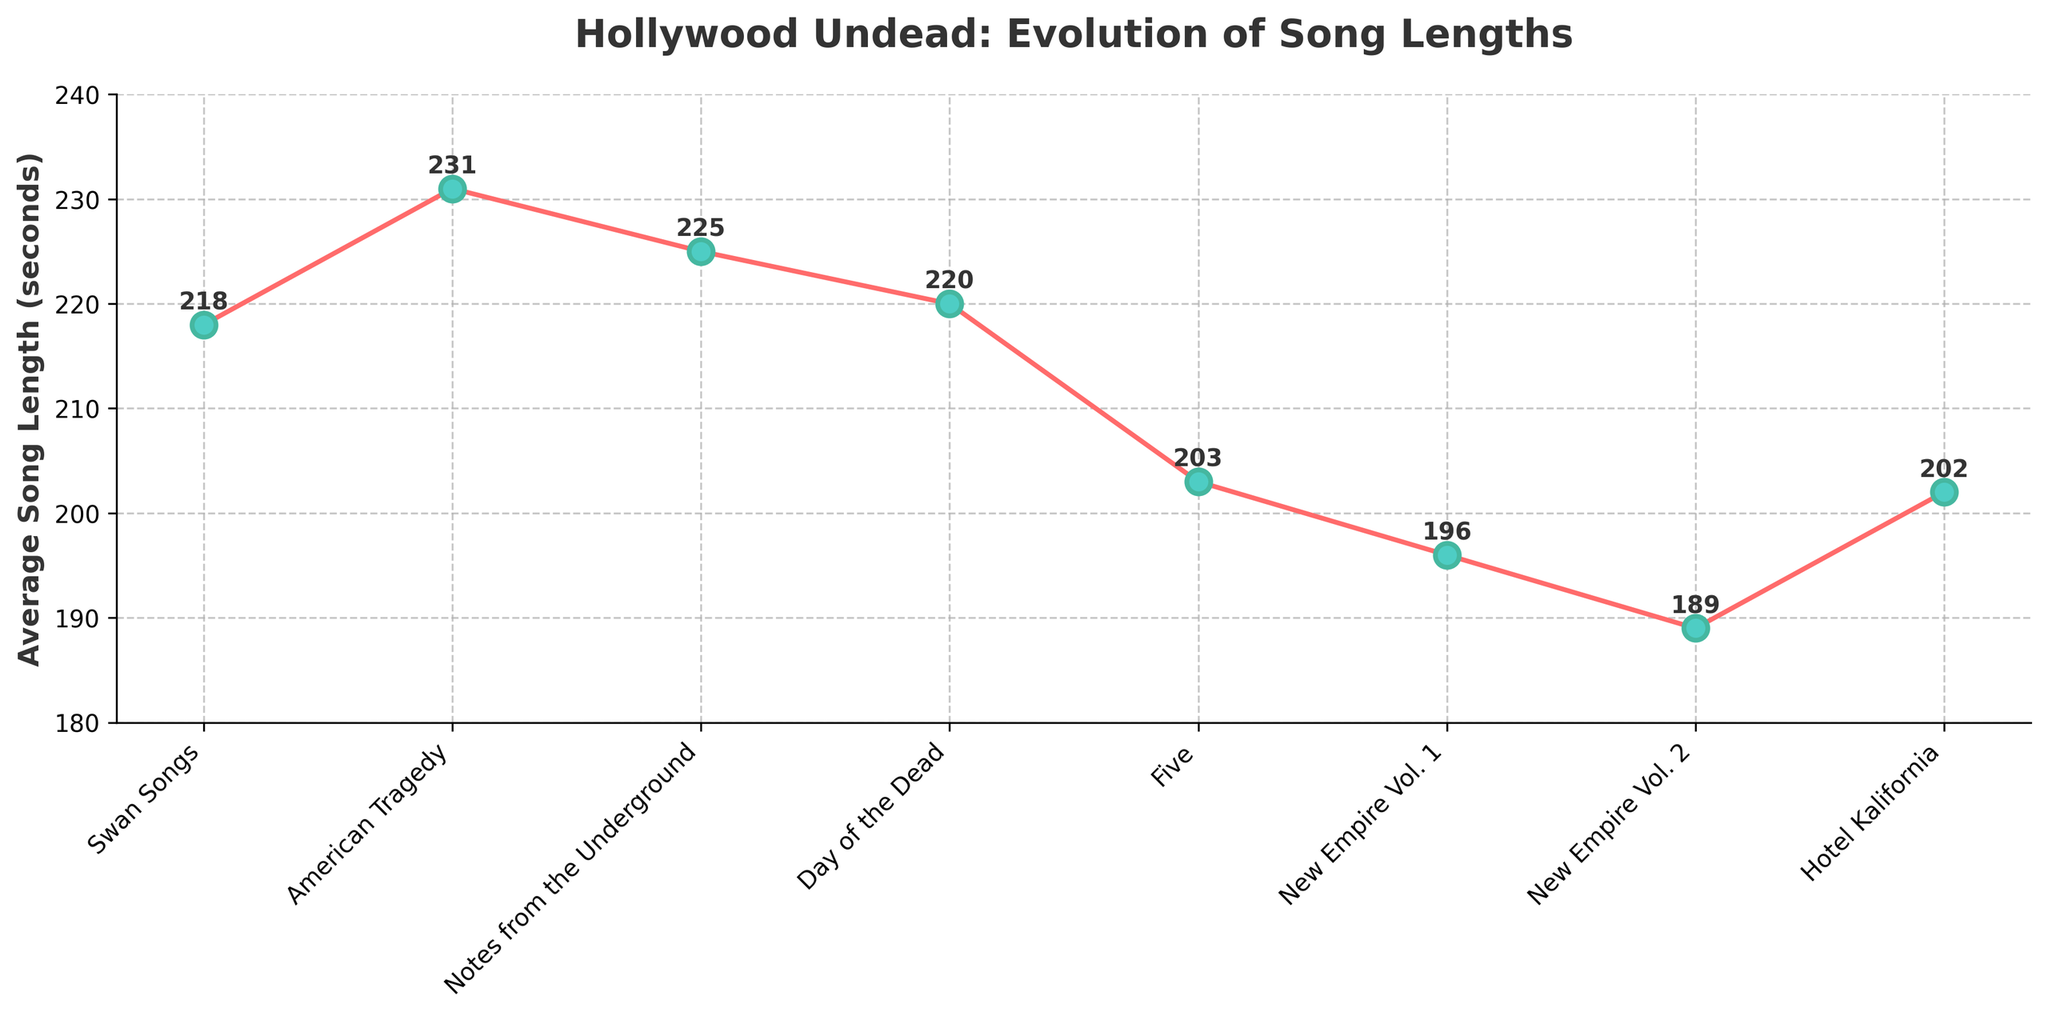How many albums have an average song length greater than 210 seconds? Look at each album's average song length and count how many are above 210 seconds. "Swan Songs" (218), "American Tragedy" (231), "Notes from the Underground" (225), and "Day of the Dead" (220) all have average song lengths greater than 210 seconds.
Answer: 4 Which album has the shortest average song length? Compare the average song length for all the albums. "New Empire Vol. 2" has the shortest average song length at 189 seconds.
Answer: New Empire Vol. 2 Are there any albums with the same average song length? Check the values of average song lengths and see if any values are repeated. There are no repeated values in this dataset.
Answer: No What is the difference in average song length between "American Tragedy" and "New Empire Vol. 1"? Subtract the average song length of "New Empire Vol. 1" from that of "American Tragedy": 231 - 196 = 35 seconds.
Answer: 35 seconds What is the overall trend in average song lengths over time? Observe the plot line or the sequence of average song lengths from "Swan Songs" to "Hotel Kalifornia". The trend shows a general decrease in average song lengths over time.
Answer: Decreasing Which album shows the largest change in average song length compared to its previous album? Calculate the absolute differences between consecutive albums: "Swan Songs" to "American Tragedy" (13), "American Tragedy" to "Notes from the Underground" (6), and so on. "American Tragedy" to "Five" shows the largest drop: 231 - 203 = 28 seconds.
Answer: American Tragedy to Five If you average the song lengths of "Day of the Dead" and "Hotel Kalifornia," what value do you get? Add the average song lengths of "Day of the Dead" and "Hotel Kalifornia" and divide by 2: (220 + 202) / 2 = 211 seconds.
Answer: 211 seconds How much has the average song length decreased from "Swan Songs" to "Hotel Kalifornia"? Subtract the average song length of "Hotel Kalifornia" from that of "Swan Songs": 218 - 202 = 16 seconds.
Answer: 16 seconds Is the average song length of "Notes from the Underground" greater than that of "Five"? Compare the average song lengths of the two albums: 225 vs. 203. Yes, 225 is greater than 203.
Answer: Yes What visual features help distinguish the average song lengths for different albums? Consider the graphical attributes used: the plot uses red lines with teal markers, clear text labels for each album, and numerical annotations next to each data point, which help identify differing song lengths.
Answer: Red lines with teal markers, clear text labels, numerical annotations 